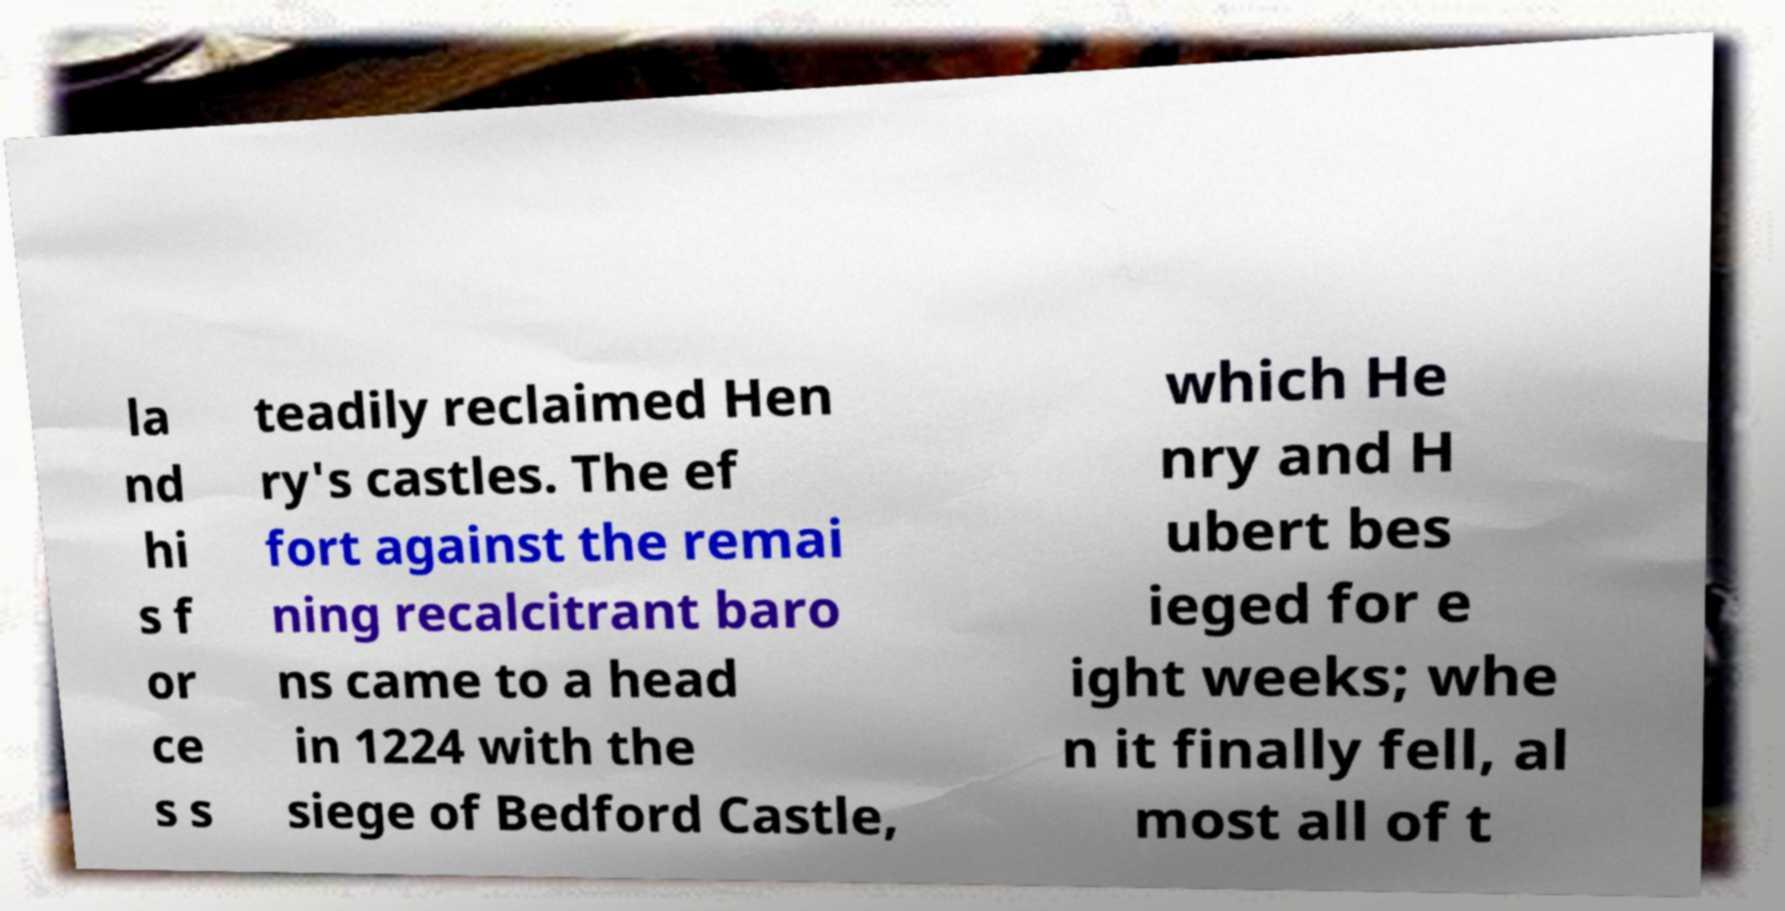Please read and relay the text visible in this image. What does it say? la nd hi s f or ce s s teadily reclaimed Hen ry's castles. The ef fort against the remai ning recalcitrant baro ns came to a head in 1224 with the siege of Bedford Castle, which He nry and H ubert bes ieged for e ight weeks; whe n it finally fell, al most all of t 